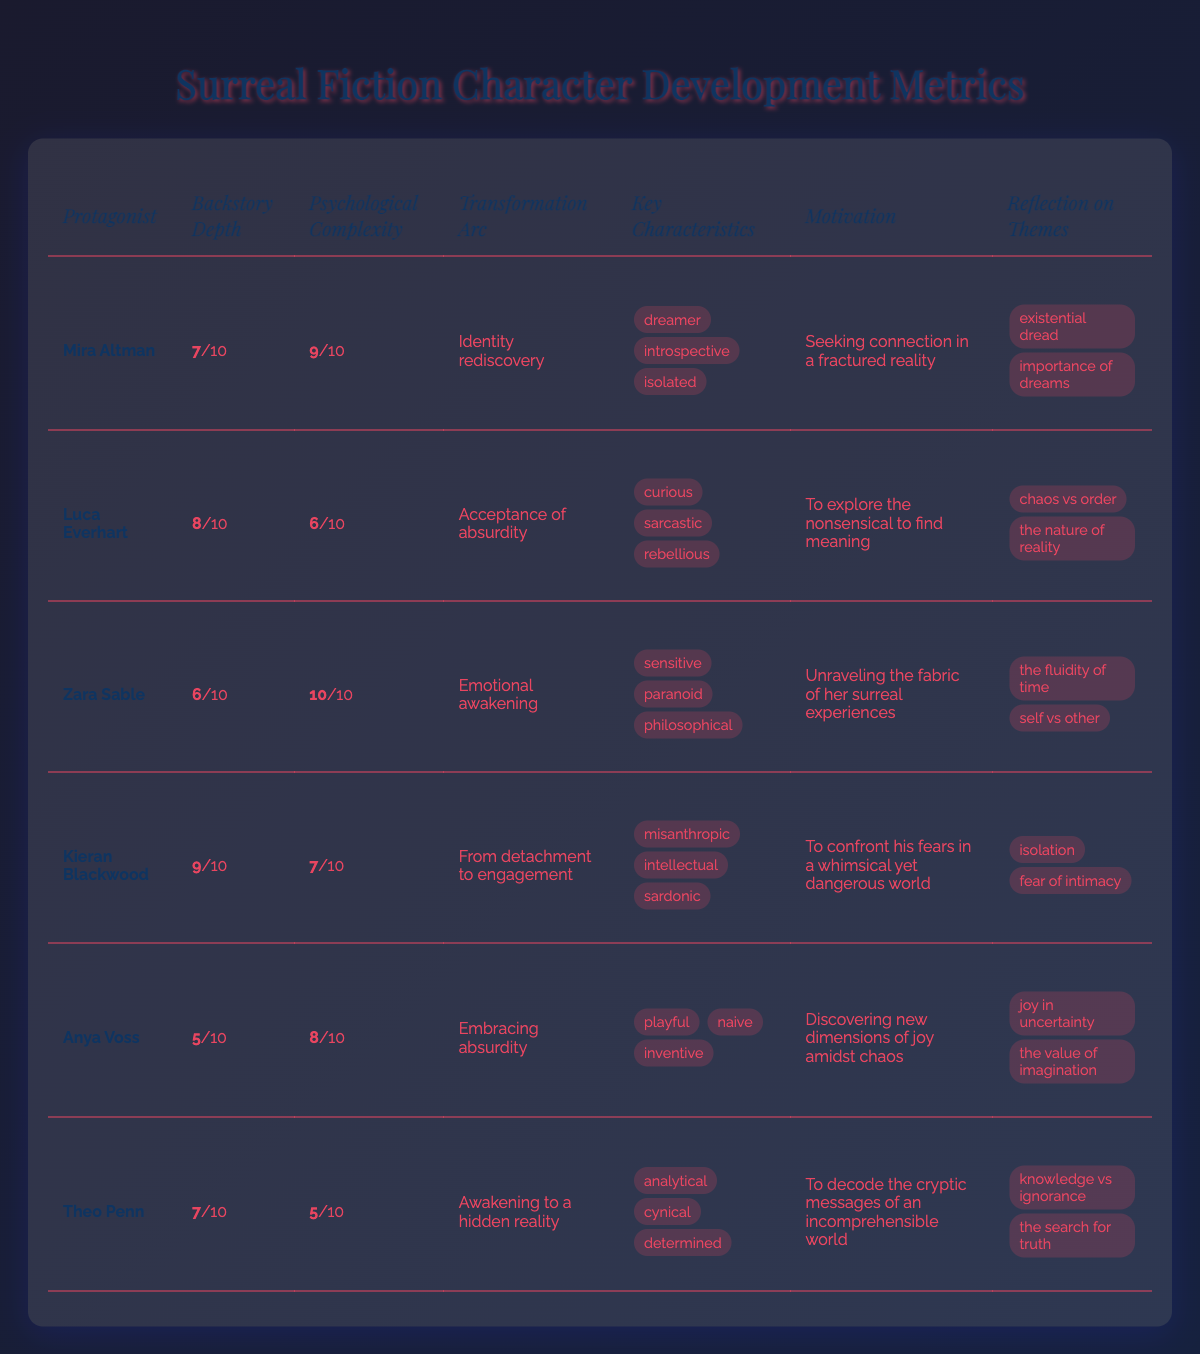What is the backstory depth of Zara Sable? The table lists Zara Sable's backstory depth as 6, which can be found in the "Backstory Depth" column corresponding to her name.
Answer: 6 Which protagonist has the highest psychological complexity? Zara Sable has the highest psychological complexity score of 10, as indicated in the "Psychological Complexity" column, which is higher than all other protagonists.
Answer: Zara Sable What is the transformation arc of Kieran Blackwood? The transformation arc of Kieran Blackwood is listed as "From detachment to engagement" under the "Transformation Arc" column.
Answer: From detachment to engagement What are the key characteristics of Mira Altman? Mira Altman's key characteristics are detailed in the "Key Characteristics" column, which lists her as a dreamer, introspective, and isolated.
Answer: dreamer, introspective, isolated What is the average backstory depth of all protagonists? To calculate the average backstory depth, sum all the values (7 + 8 + 6 + 9 + 5 + 7) = 42 and divide by the number of protagonists (6): 42/6 = 7.
Answer: 7 Does any protagonist have a motivation related to chaos? Luca Everhart’s motivation is "To explore the nonsensical to find meaning," which ties to chaos, confirming a yes answer.
Answer: Yes Which protagonist’s transformation arc reflects acceptance of absurdity and has the lowest psychological complexity? Anya Voss has a transformation arc of "Embracing absurdity" and a psychological complexity of 8, which is lower than Mira Altman (9) and Zara Sable (10).
Answer: Anya Voss Which protagonist has the least depth in backstory? Anya Voss has the least depth in backstory with a score of 5, notably lower than the others indicated in the respective column.
Answer: Anya Voss What is the total number of reflection themes for Theo Penn? Theo Penn has two reflection themes listed: "knowledge vs ignorance" and "the search for truth," thus totaling two themes.
Answer: 2 How many protagonists have a transformation arc that suggests a form of awakening? Both Zara Sable’s "Emotional awakening" and Theo Penn’s "Awakening to a hidden reality" imply an awakening transformation arc, totaling two protagonists.
Answer: 2 